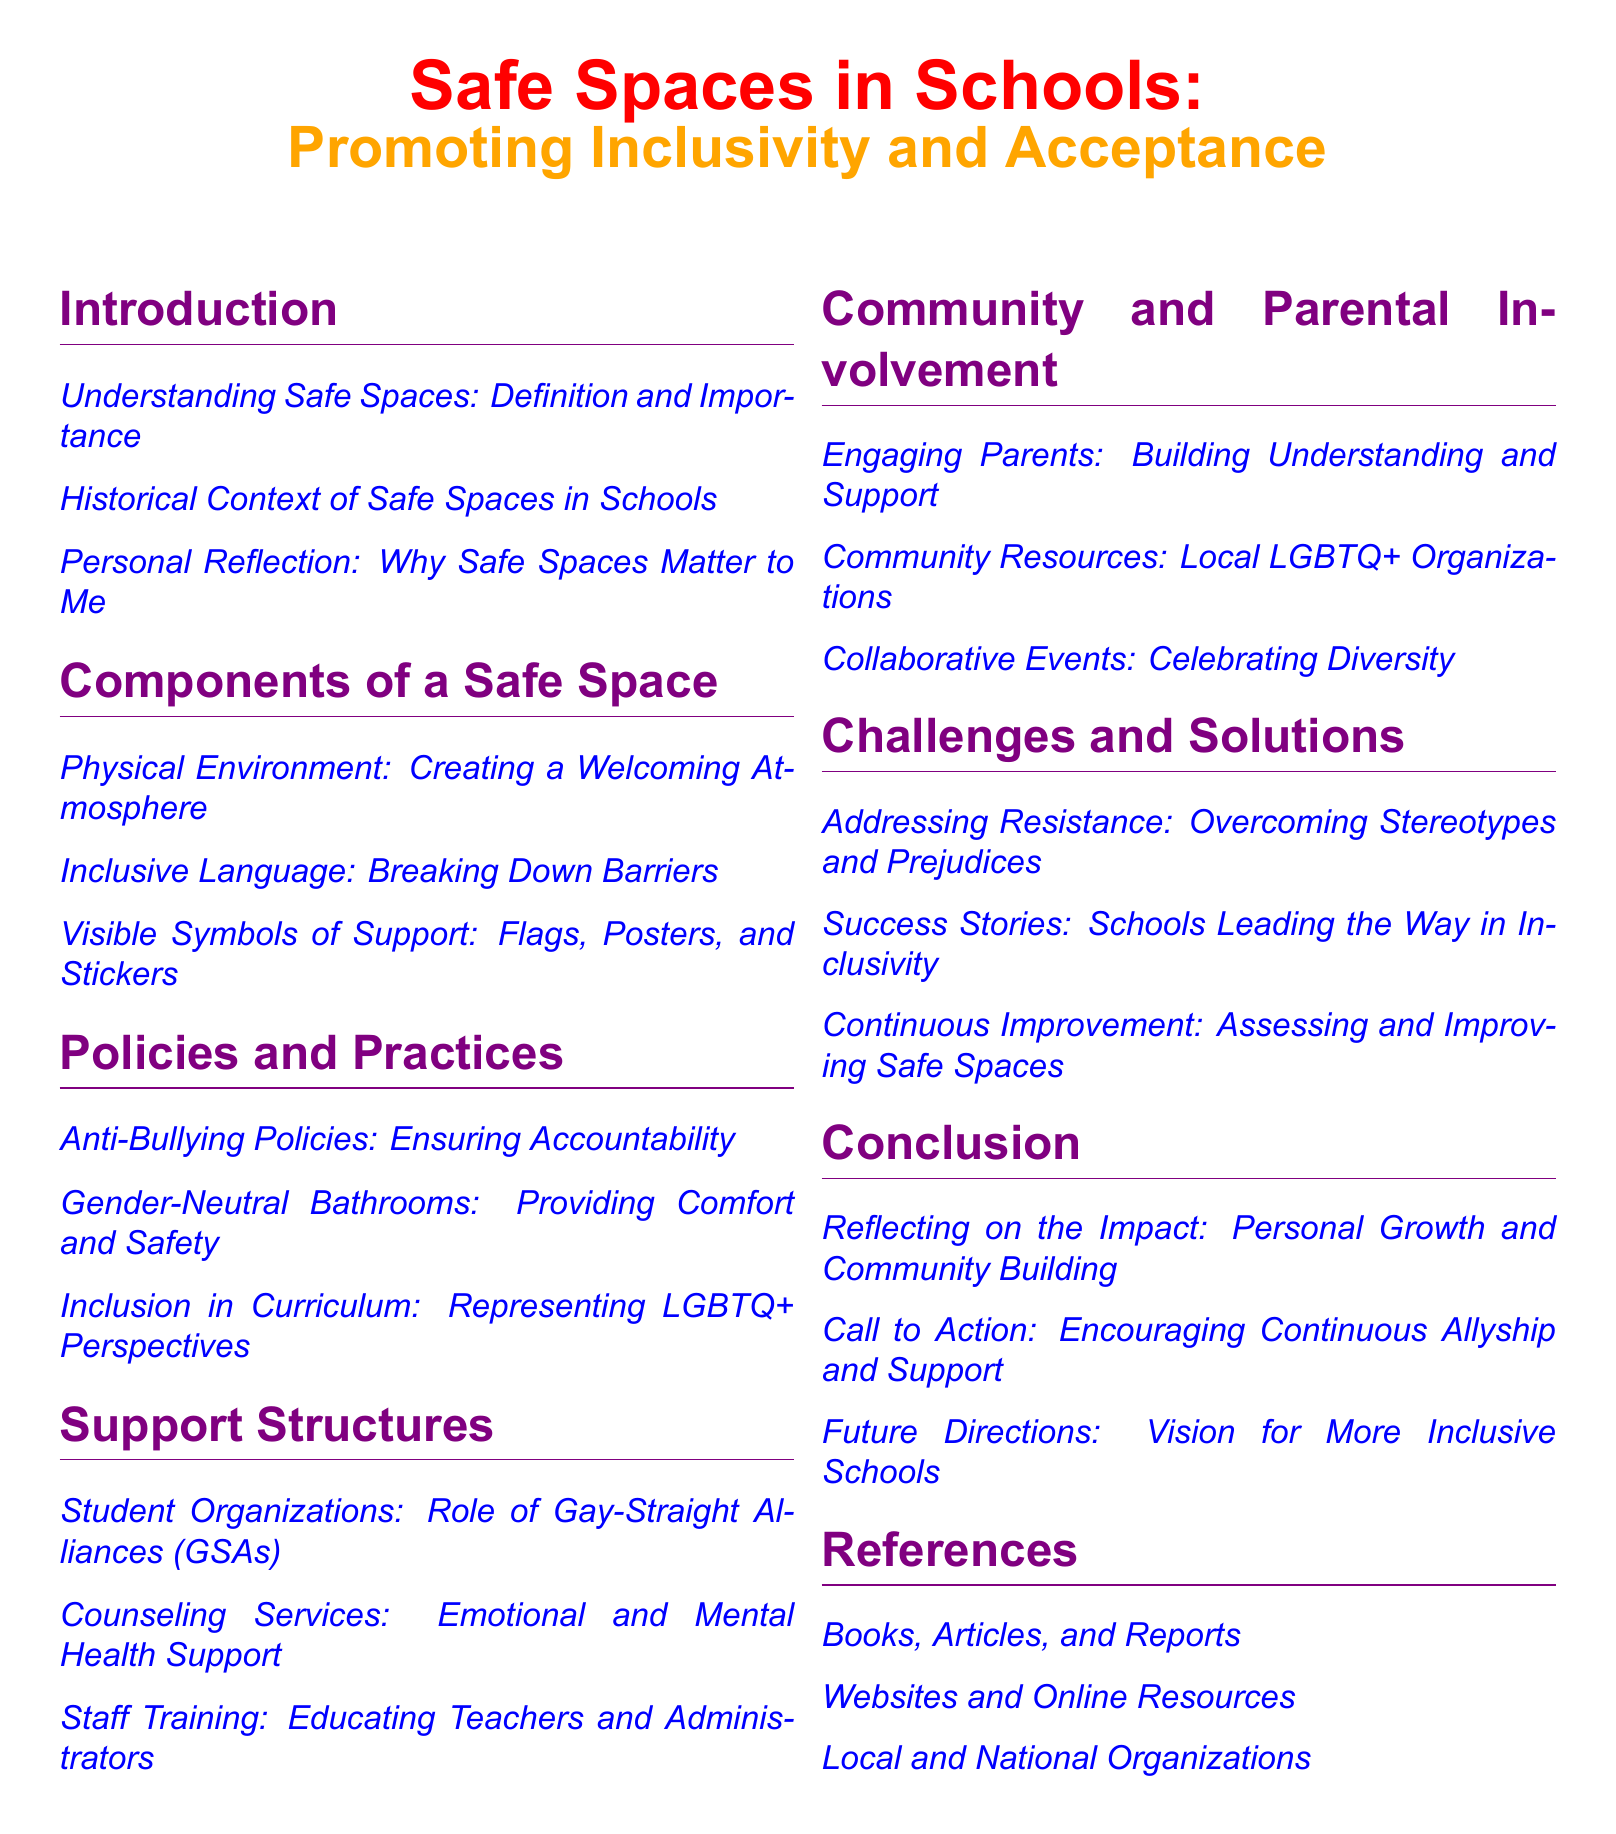What is the title of the document? The title of the document is prominently featured at the top of the table of contents.
Answer: Safe Spaces in Schools: Promoting Inclusivity and Acceptance How many main sections are in the document? Counting the main sections listed in the table of contents reveals the total number.
Answer: 6 What is one component of a safe space mentioned? The document specifies several components of a safe space under one of its main sections.
Answer: Inclusive Language: Breaking Down Barriers What type of policies are discussed under the 'Policies and Practices' section? The table of contents outlines specific types of policies related to inclusivity.
Answer: Anti-Bullying Policies What is the purpose of student organizations like GSAs? The document discusses their role in providing support within the school environment.
Answer: Role of Gay-Straight Alliances (GSAs) What should parents engage in to support safe spaces? The table of contents suggests a specific type of involvement to facilitate understanding.
Answer: Building Understanding and Support What does the 'Challenges and Solutions' section address? This section provides a focus on specific difficulties faced in promoting safety in schools.
Answer: Overcoming Stereotypes and Prejudices What does the author reflect on in the conclusion? The conclusion contains a personal reflection on a specific outcome of safe spaces in schools.
Answer: Personal Growth and Community Building 